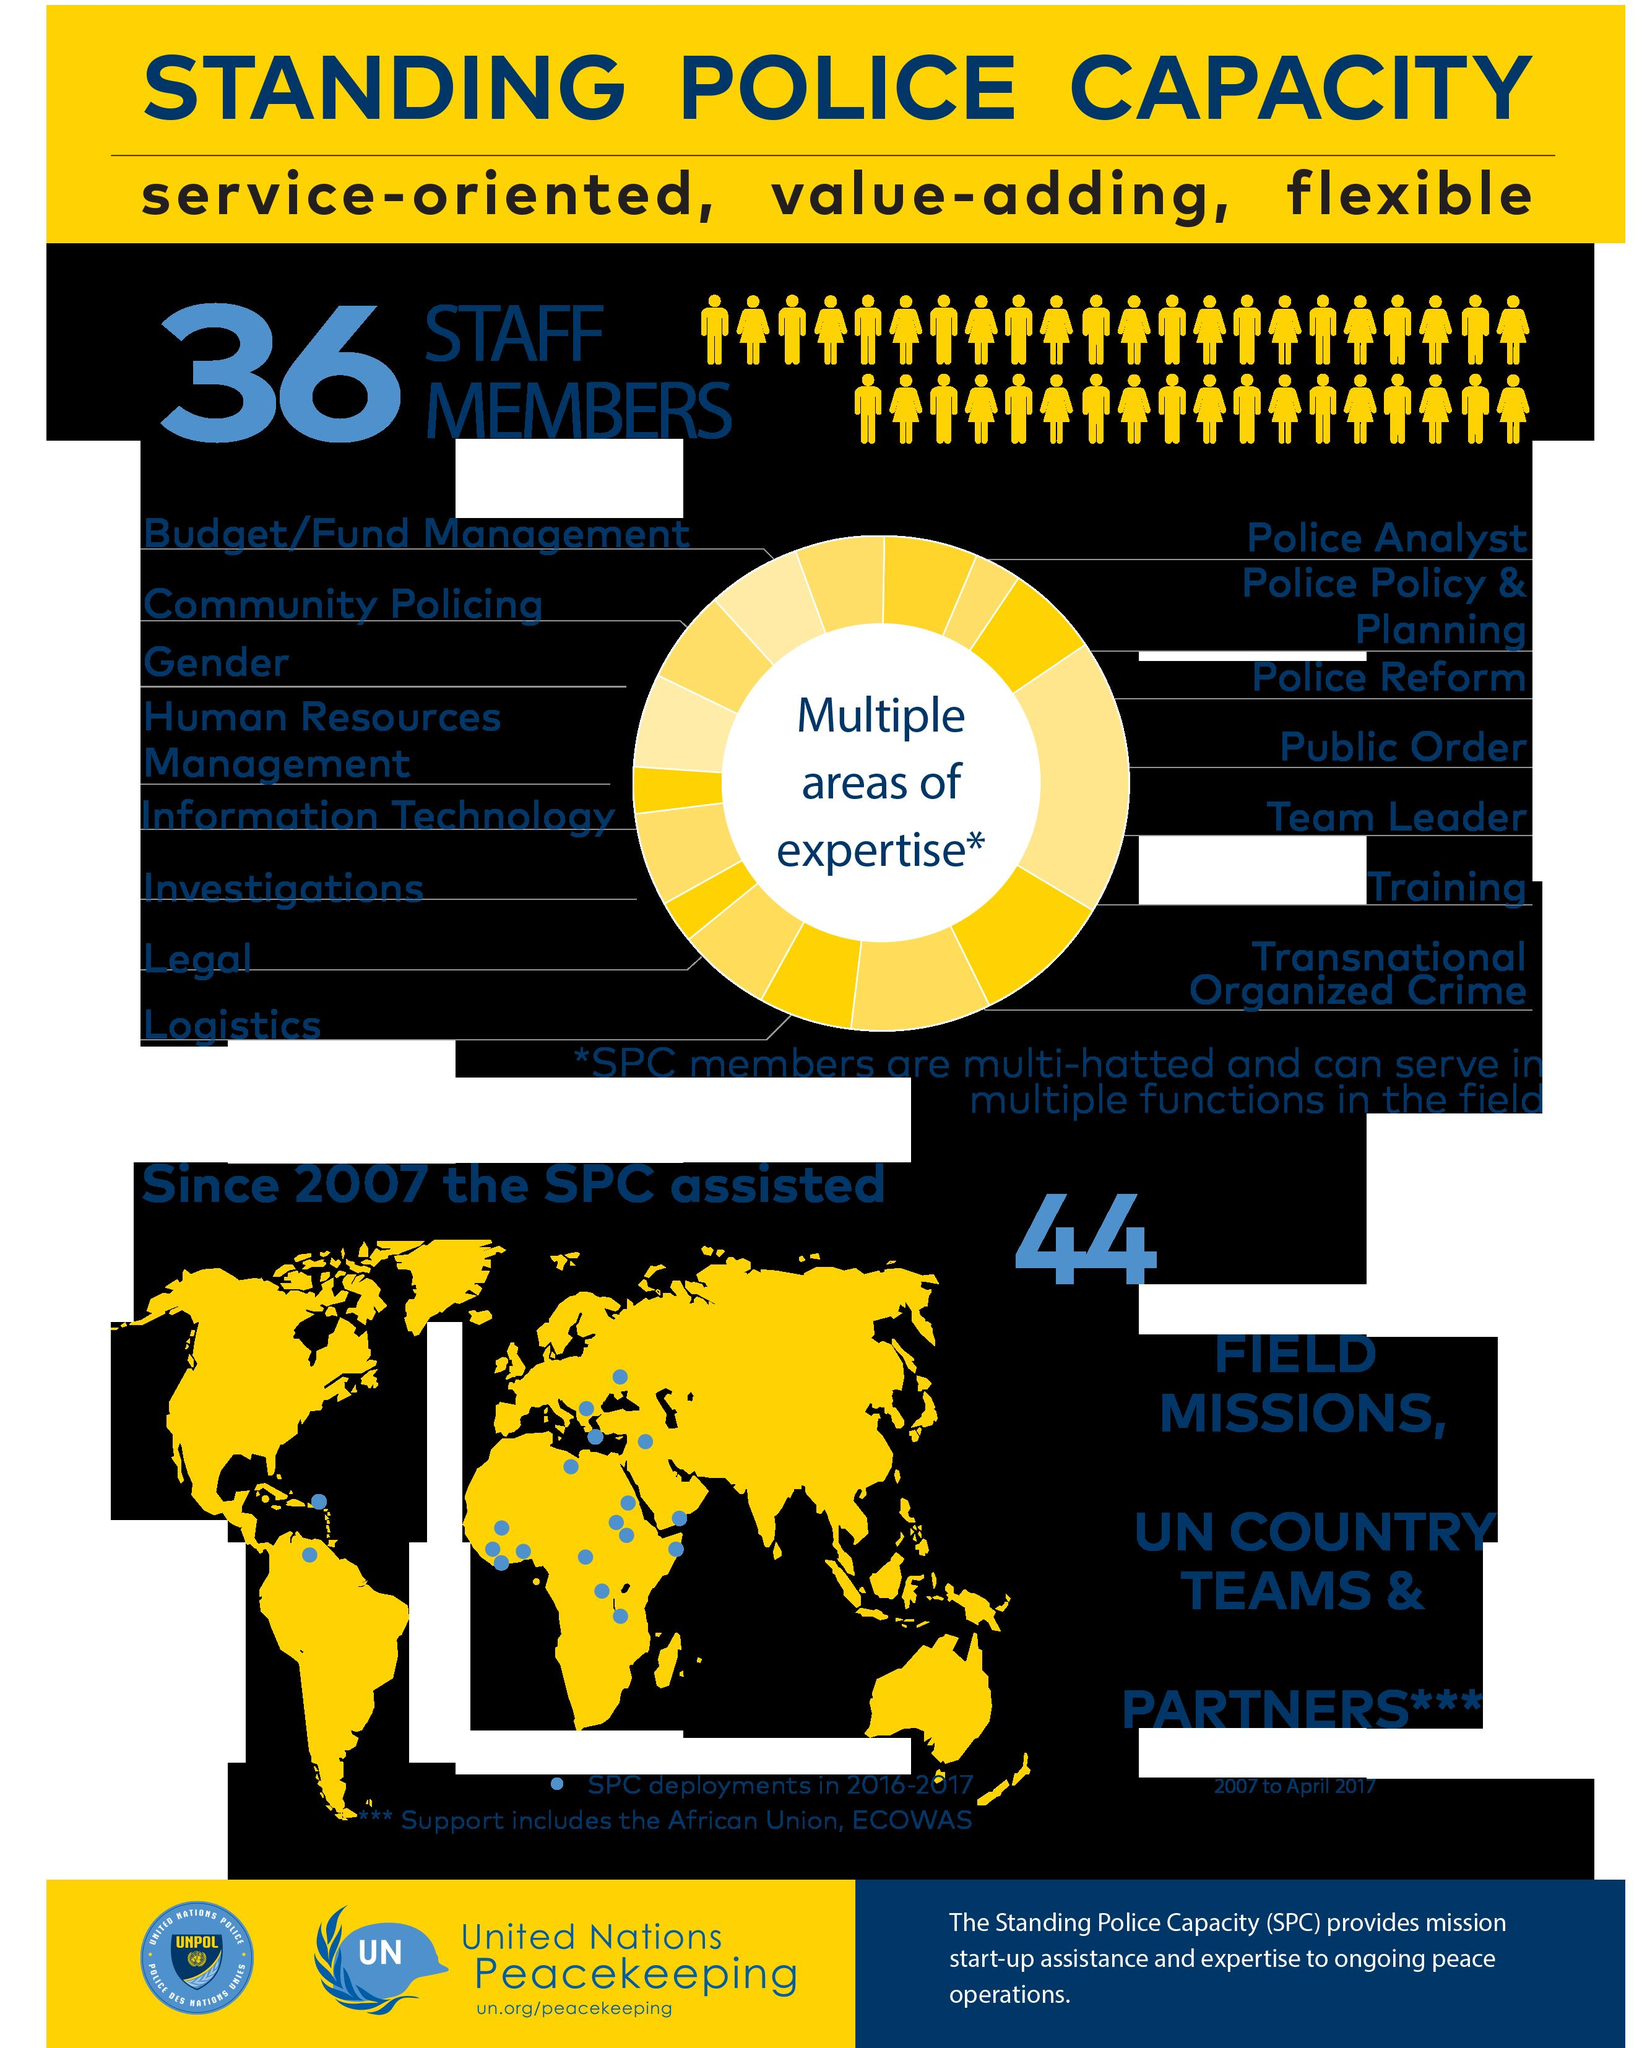Draw attention to some important aspects in this diagram. In the infographic, yellow represents the continents. The infographic indicates that Australia did not have a SPARC deployment in 2016-2017, according to the map shown. 